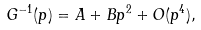<formula> <loc_0><loc_0><loc_500><loc_500>G ^ { - 1 } ( p ) = A + B p ^ { 2 } + O ( p ^ { 4 } ) ,</formula> 